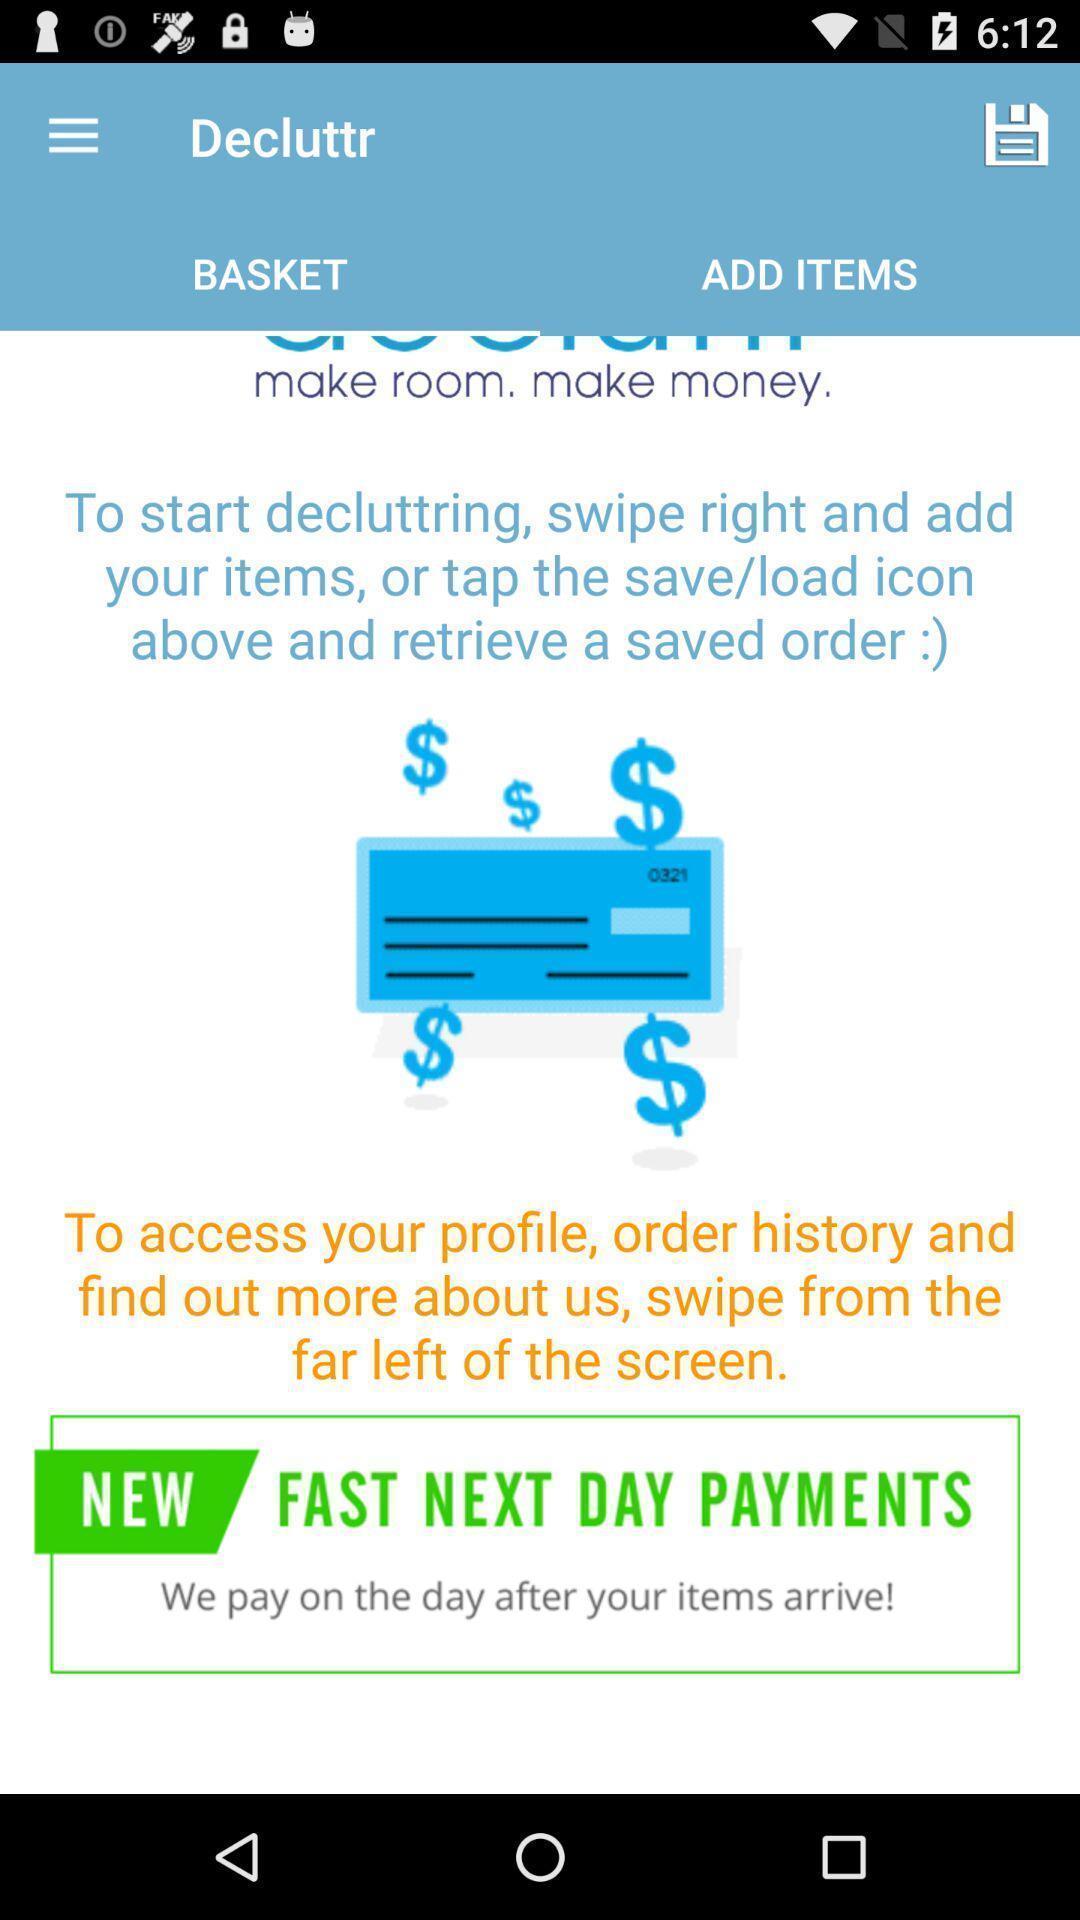What is the overall content of this screenshot? Page displaying to add items in a selling app. 